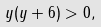Convert formula to latex. <formula><loc_0><loc_0><loc_500><loc_500>y ( y + 6 ) > 0 ,</formula> 